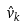Convert formula to latex. <formula><loc_0><loc_0><loc_500><loc_500>\hat { v } _ { k }</formula> 